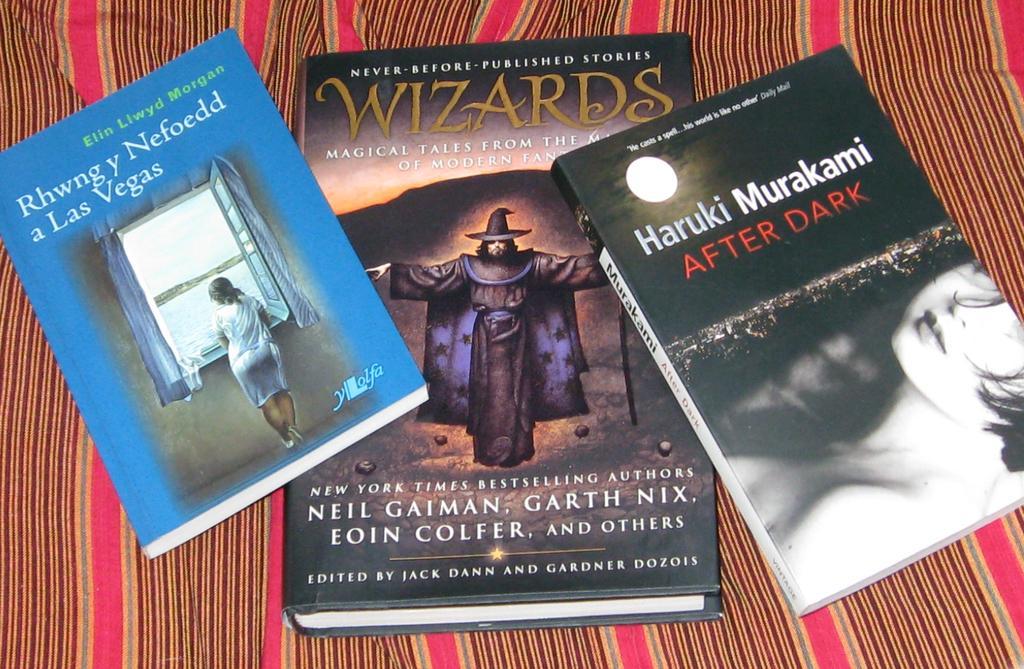How would you summarize this image in a sentence or two? In this image we can see three books are kept on the the surface. This book is in blue color on which we can see the windows and a person is standing near. On this book we can see a person wearing different costume and on this book we can see a woman face and some edited text on it. 